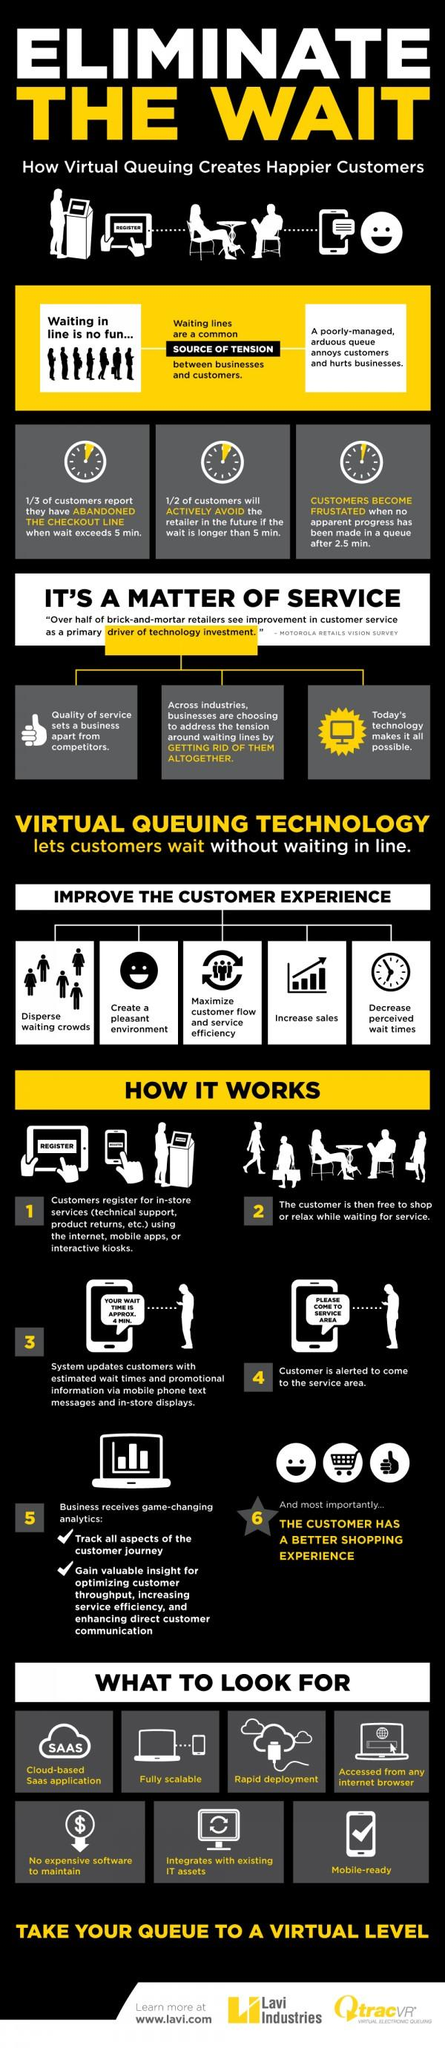Give some essential details in this illustration. It is expected that there will be 7 features in the virtual queuing technology. Waiting in lines is a common source of tension for many people. In the step where all aspects of the customer journey can be tracked, it is possible to gain a comprehensive understanding of the customer's journey and identify areas for improvement. After approximately 2.5 minutes, customers may begin to feel frustrated. Improving customer experience involves maximizing customer flow and service efficiency, which is the third aspect in achieving this goal. 